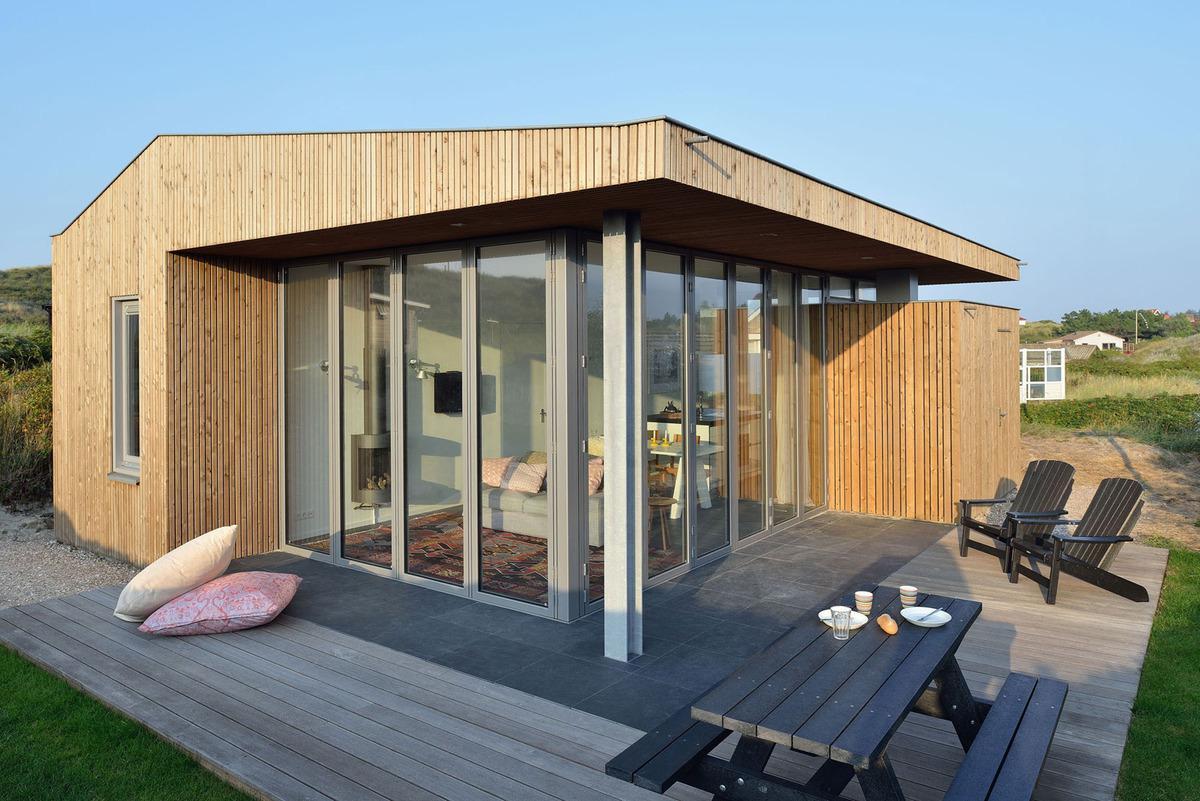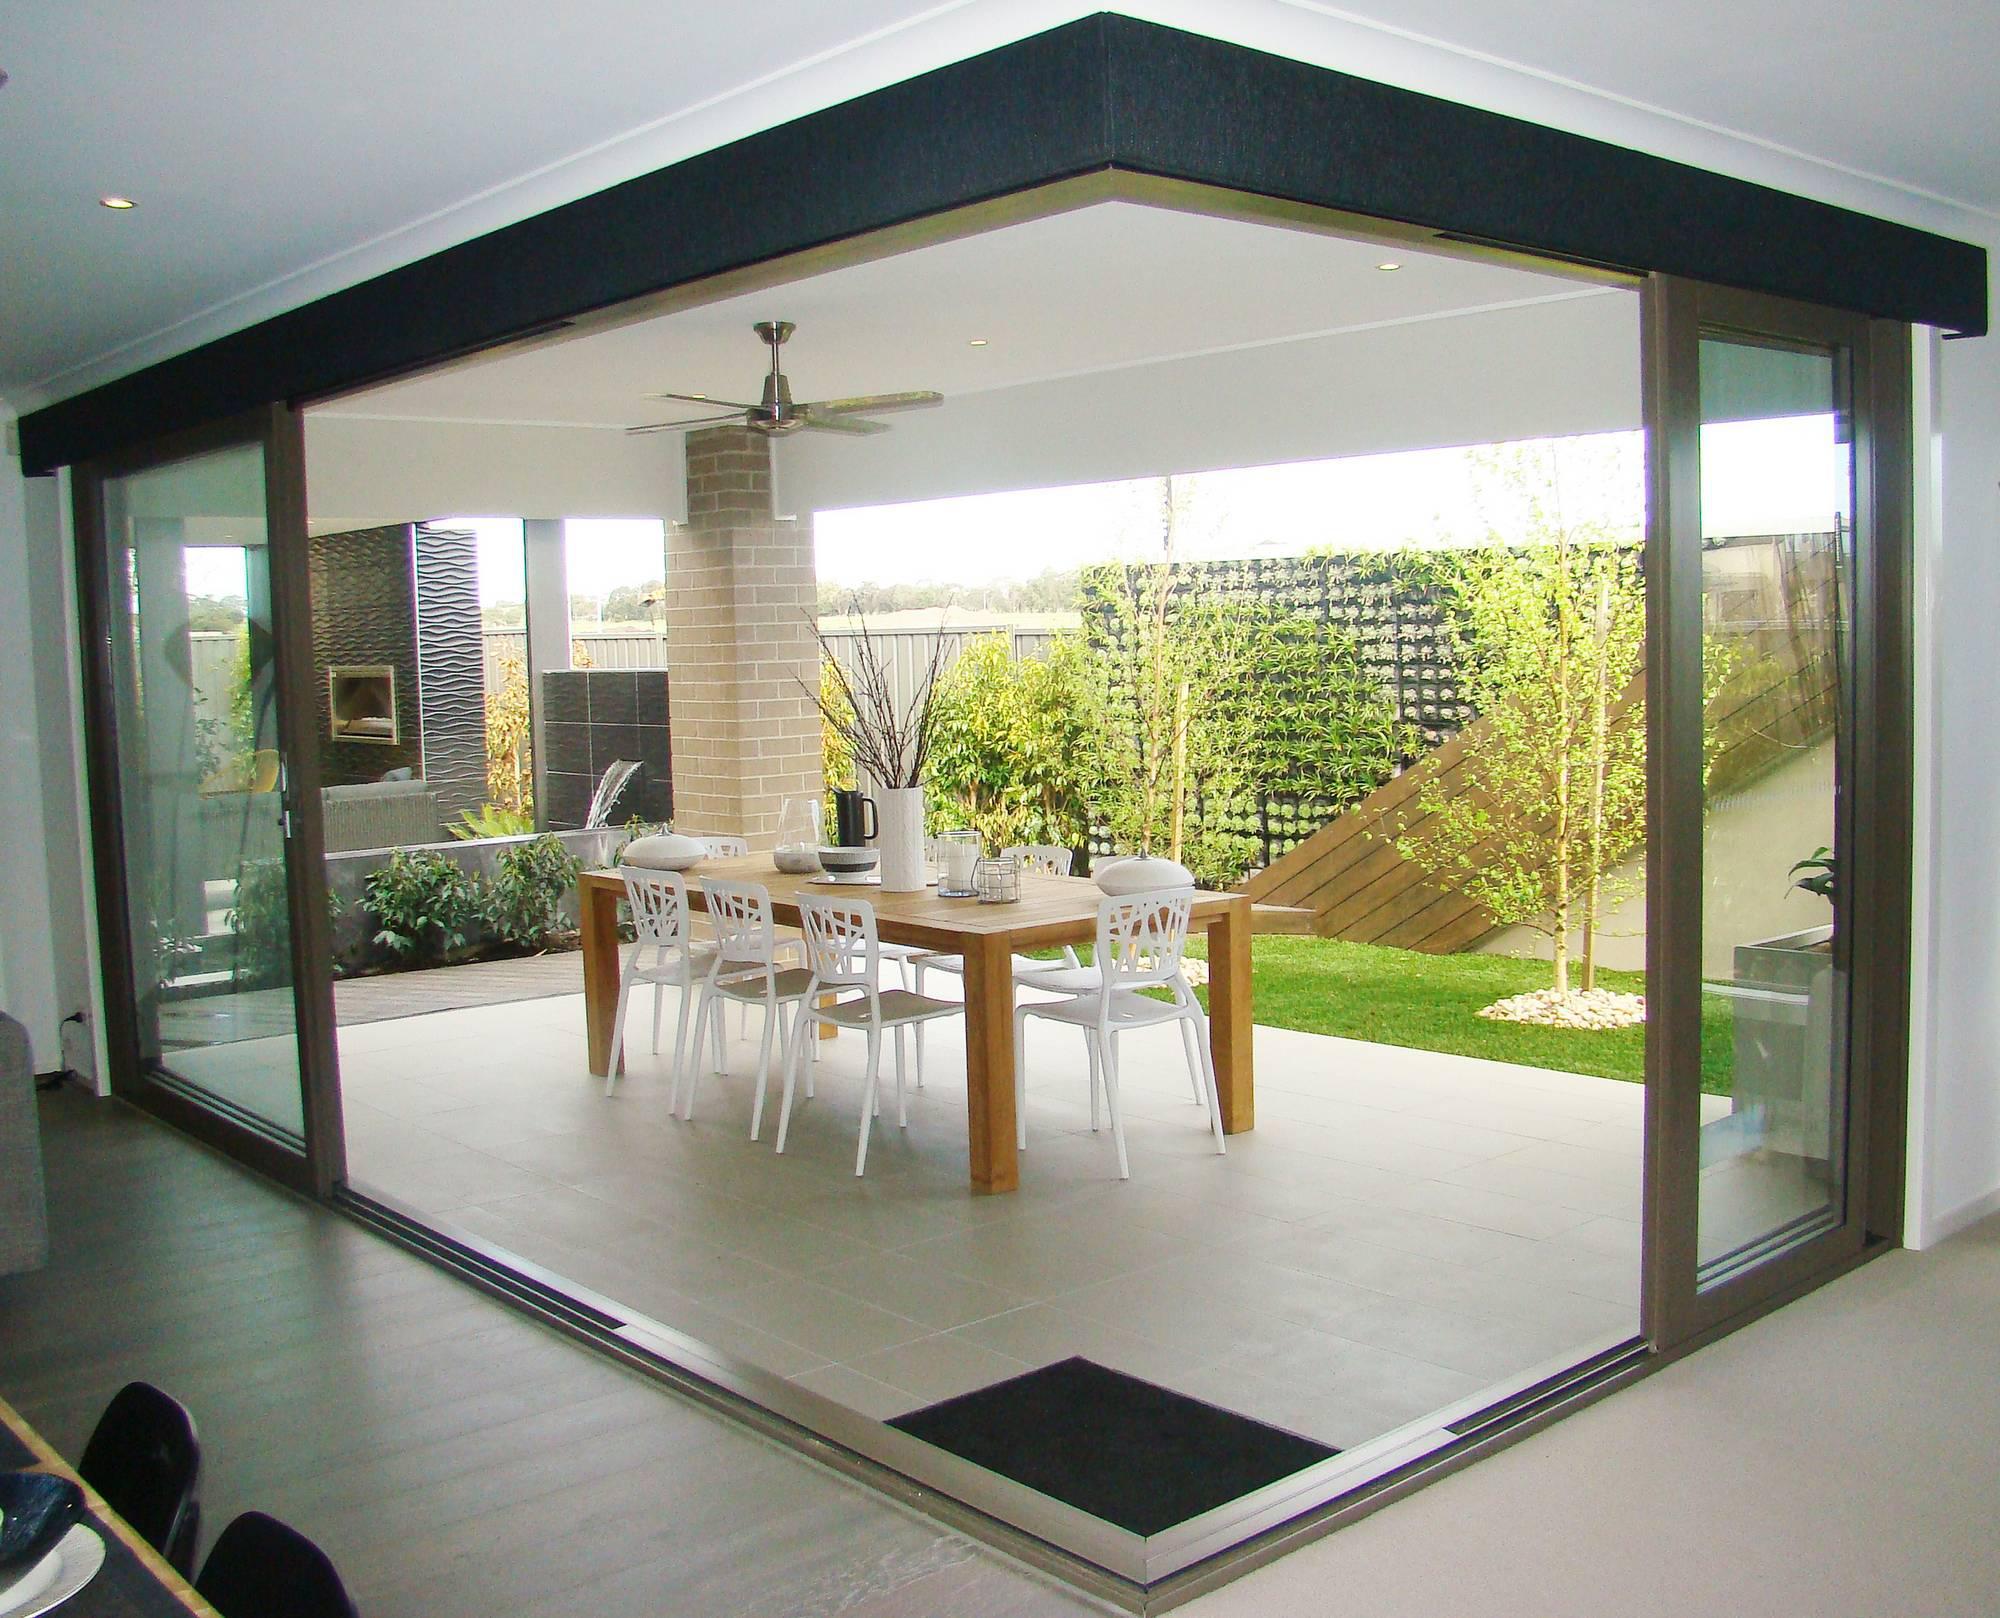The first image is the image on the left, the second image is the image on the right. For the images displayed, is the sentence "The doors are open in the right image." factually correct? Answer yes or no. Yes. 